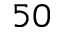<formula> <loc_0><loc_0><loc_500><loc_500>5 0</formula> 